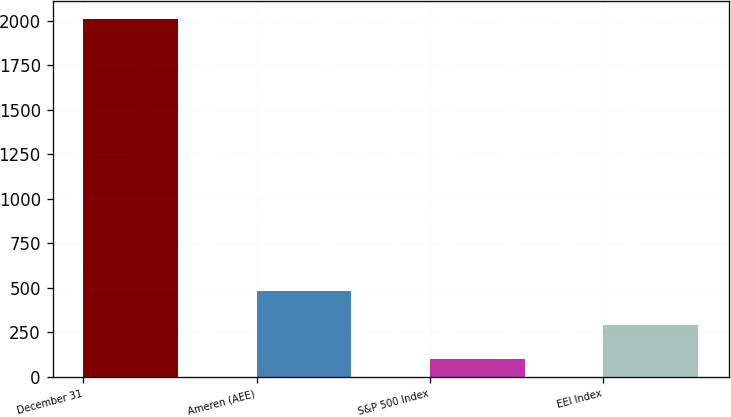Convert chart to OTSL. <chart><loc_0><loc_0><loc_500><loc_500><bar_chart><fcel>December 31<fcel>Ameren (AEE)<fcel>S&P 500 Index<fcel>EEI Index<nl><fcel>2011<fcel>483.89<fcel>102.11<fcel>293<nl></chart> 